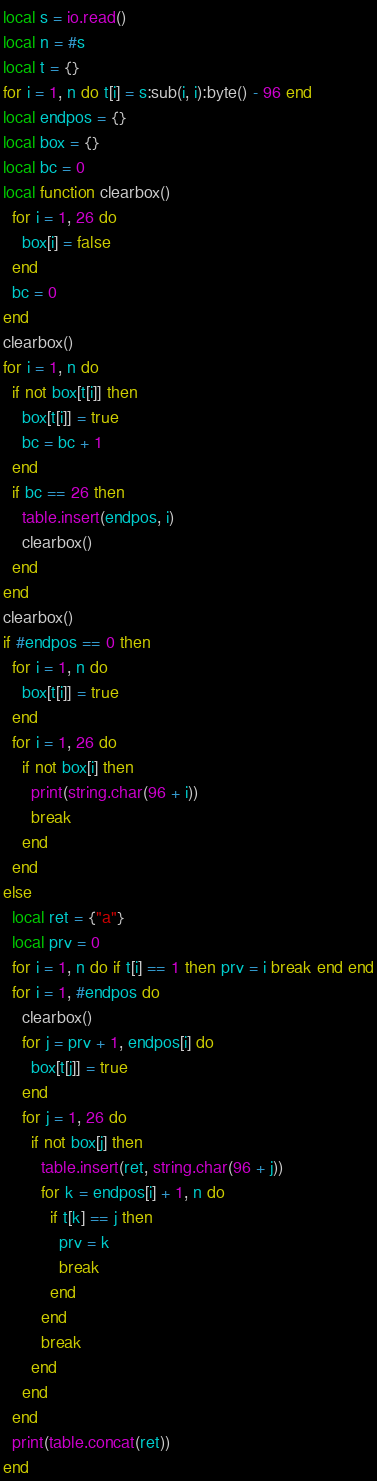Convert code to text. <code><loc_0><loc_0><loc_500><loc_500><_Lua_>local s = io.read()
local n = #s
local t = {}
for i = 1, n do t[i] = s:sub(i, i):byte() - 96 end
local endpos = {}
local box = {}
local bc = 0
local function clearbox()
  for i = 1, 26 do
    box[i] = false
  end
  bc = 0
end
clearbox()
for i = 1, n do
  if not box[t[i]] then
    box[t[i]] = true
    bc = bc + 1
  end
  if bc == 26 then
    table.insert(endpos, i)
    clearbox()
  end
end
clearbox()
if #endpos == 0 then
  for i = 1, n do
    box[t[i]] = true
  end
  for i = 1, 26 do
    if not box[i] then
      print(string.char(96 + i))
      break
    end
  end
else
  local ret = {"a"}
  local prv = 0
  for i = 1, n do if t[i] == 1 then prv = i break end end
  for i = 1, #endpos do
    clearbox()
    for j = prv + 1, endpos[i] do
      box[t[j]] = true
    end
    for j = 1, 26 do
      if not box[j] then
        table.insert(ret, string.char(96 + j))
        for k = endpos[i] + 1, n do
          if t[k] == j then
            prv = k
            break
          end
        end
        break
      end
    end
  end
  print(table.concat(ret))
end
</code> 